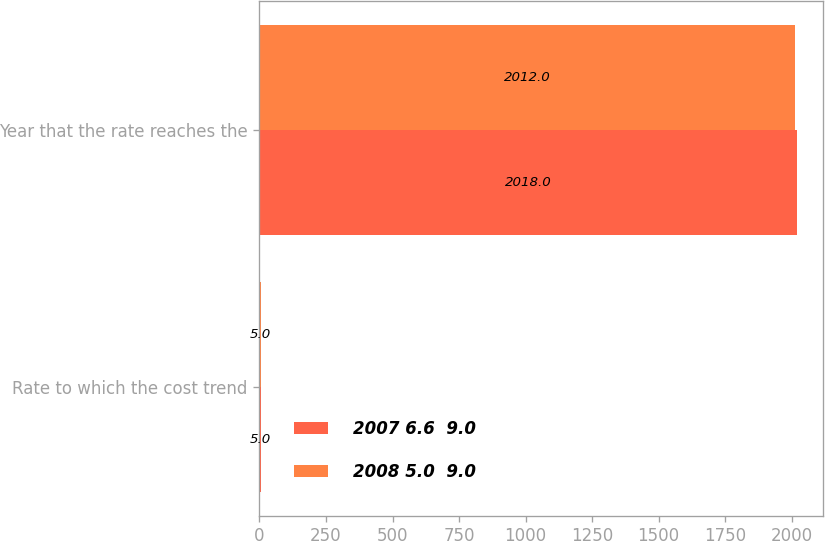Convert chart to OTSL. <chart><loc_0><loc_0><loc_500><loc_500><stacked_bar_chart><ecel><fcel>Rate to which the cost trend<fcel>Year that the rate reaches the<nl><fcel>2007 6.6  9.0<fcel>5<fcel>2018<nl><fcel>2008 5.0  9.0<fcel>5<fcel>2012<nl></chart> 